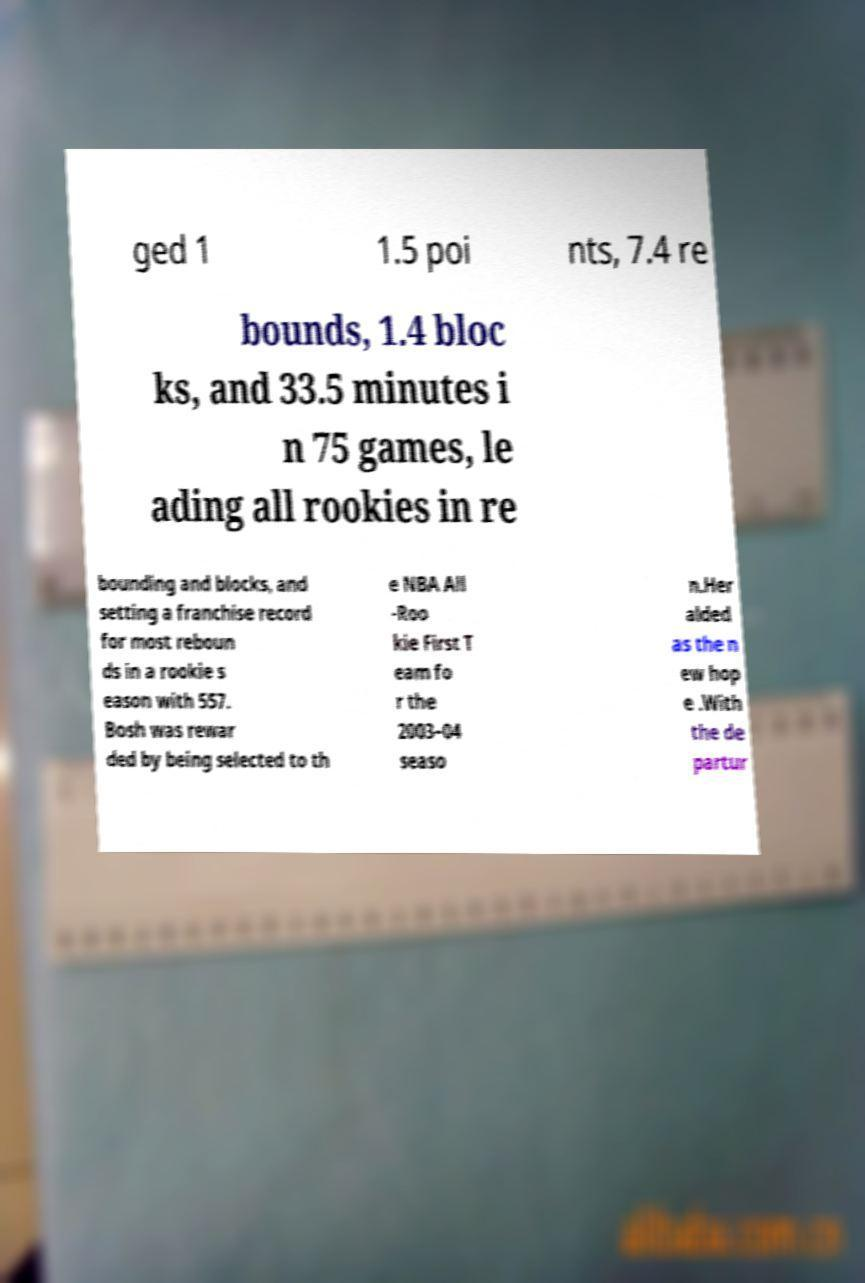I need the written content from this picture converted into text. Can you do that? ged 1 1.5 poi nts, 7.4 re bounds, 1.4 bloc ks, and 33.5 minutes i n 75 games, le ading all rookies in re bounding and blocks, and setting a franchise record for most reboun ds in a rookie s eason with 557. Bosh was rewar ded by being selected to th e NBA All -Roo kie First T eam fo r the 2003–04 seaso n.Her alded as the n ew hop e .With the de partur 